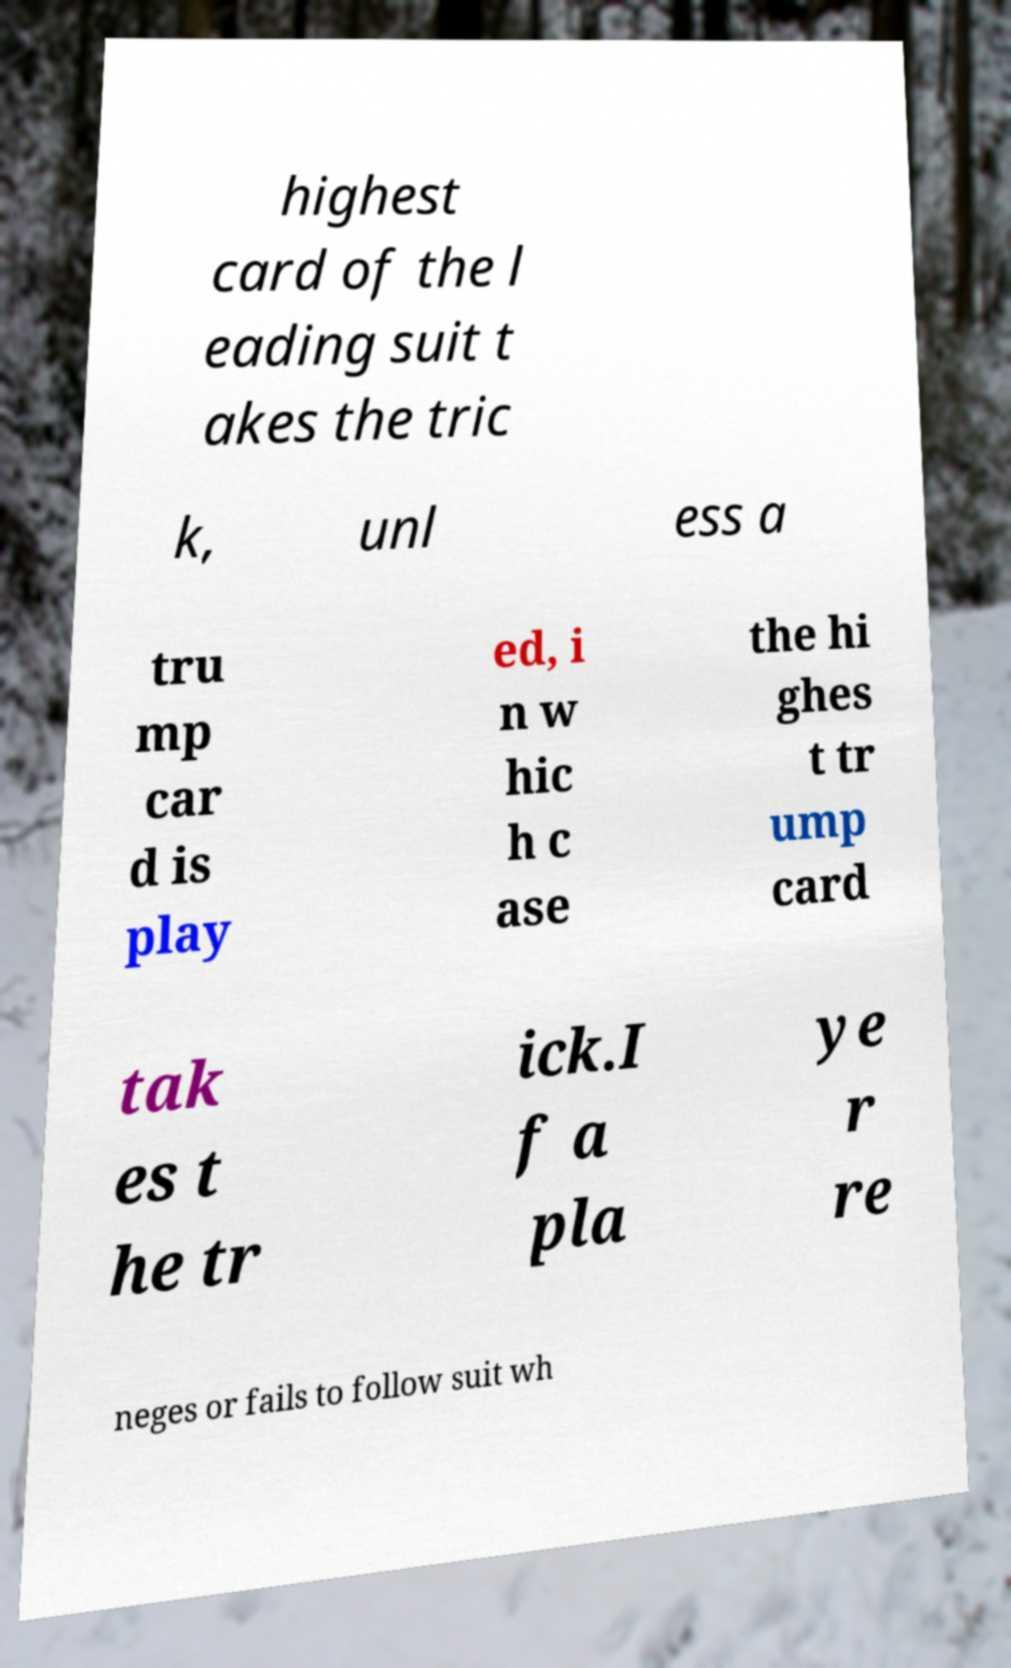Can you accurately transcribe the text from the provided image for me? highest card of the l eading suit t akes the tric k, unl ess a tru mp car d is play ed, i n w hic h c ase the hi ghes t tr ump card tak es t he tr ick.I f a pla ye r re neges or fails to follow suit wh 